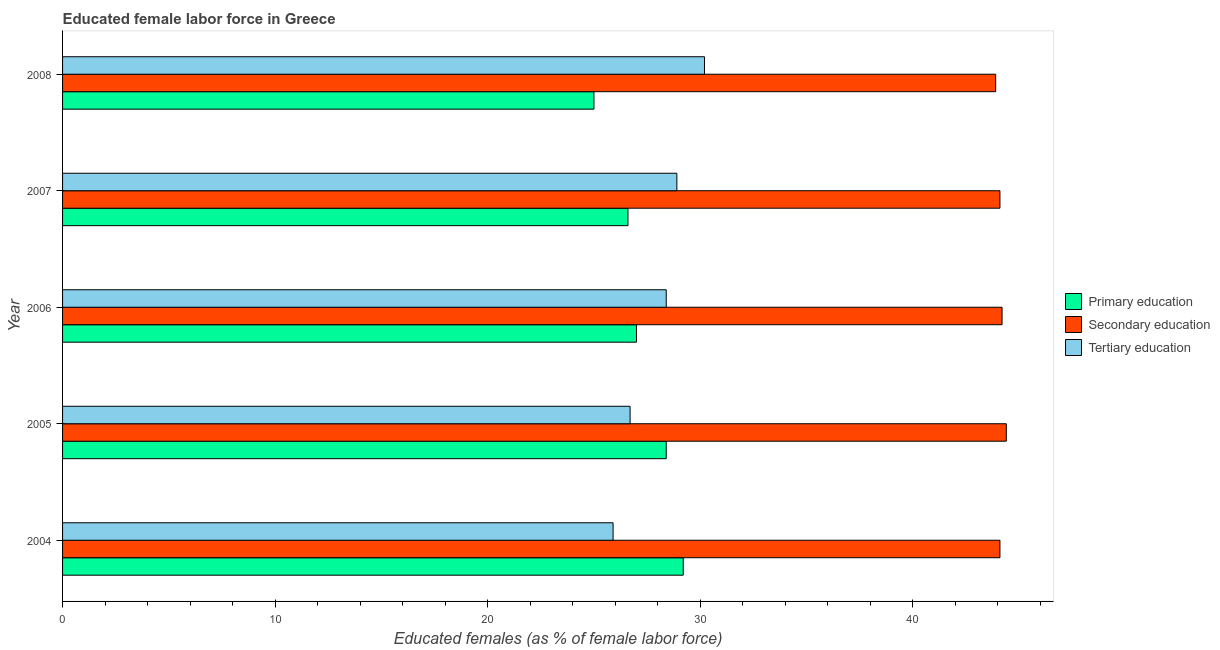How many different coloured bars are there?
Offer a terse response. 3. How many groups of bars are there?
Provide a short and direct response. 5. How many bars are there on the 4th tick from the top?
Your response must be concise. 3. What is the label of the 2nd group of bars from the top?
Keep it short and to the point. 2007. In how many cases, is the number of bars for a given year not equal to the number of legend labels?
Give a very brief answer. 0. What is the percentage of female labor force who received primary education in 2007?
Make the answer very short. 26.6. Across all years, what is the maximum percentage of female labor force who received primary education?
Give a very brief answer. 29.2. Across all years, what is the minimum percentage of female labor force who received tertiary education?
Offer a terse response. 25.9. In which year was the percentage of female labor force who received secondary education maximum?
Provide a short and direct response. 2005. What is the total percentage of female labor force who received tertiary education in the graph?
Your answer should be very brief. 140.1. What is the difference between the percentage of female labor force who received secondary education in 2004 and that in 2006?
Your answer should be compact. -0.1. What is the difference between the percentage of female labor force who received primary education in 2004 and the percentage of female labor force who received secondary education in 2007?
Keep it short and to the point. -14.9. What is the average percentage of female labor force who received tertiary education per year?
Your answer should be compact. 28.02. In the year 2005, what is the difference between the percentage of female labor force who received tertiary education and percentage of female labor force who received primary education?
Keep it short and to the point. -1.7. In how many years, is the percentage of female labor force who received secondary education greater than 32 %?
Keep it short and to the point. 5. What is the ratio of the percentage of female labor force who received secondary education in 2005 to that in 2006?
Your answer should be very brief. 1. What is the difference between the highest and the second highest percentage of female labor force who received tertiary education?
Offer a terse response. 1.3. In how many years, is the percentage of female labor force who received secondary education greater than the average percentage of female labor force who received secondary education taken over all years?
Give a very brief answer. 2. What does the 1st bar from the top in 2005 represents?
Your response must be concise. Tertiary education. What does the 2nd bar from the bottom in 2007 represents?
Make the answer very short. Secondary education. Is it the case that in every year, the sum of the percentage of female labor force who received primary education and percentage of female labor force who received secondary education is greater than the percentage of female labor force who received tertiary education?
Make the answer very short. Yes. Are all the bars in the graph horizontal?
Offer a terse response. Yes. What is the difference between two consecutive major ticks on the X-axis?
Your answer should be very brief. 10. Are the values on the major ticks of X-axis written in scientific E-notation?
Offer a terse response. No. Does the graph contain any zero values?
Provide a short and direct response. No. Where does the legend appear in the graph?
Keep it short and to the point. Center right. How are the legend labels stacked?
Ensure brevity in your answer.  Vertical. What is the title of the graph?
Ensure brevity in your answer.  Educated female labor force in Greece. Does "Poland" appear as one of the legend labels in the graph?
Provide a succinct answer. No. What is the label or title of the X-axis?
Make the answer very short. Educated females (as % of female labor force). What is the label or title of the Y-axis?
Your response must be concise. Year. What is the Educated females (as % of female labor force) in Primary education in 2004?
Provide a succinct answer. 29.2. What is the Educated females (as % of female labor force) of Secondary education in 2004?
Keep it short and to the point. 44.1. What is the Educated females (as % of female labor force) of Tertiary education in 2004?
Give a very brief answer. 25.9. What is the Educated females (as % of female labor force) in Primary education in 2005?
Give a very brief answer. 28.4. What is the Educated females (as % of female labor force) in Secondary education in 2005?
Your answer should be very brief. 44.4. What is the Educated females (as % of female labor force) of Tertiary education in 2005?
Your answer should be very brief. 26.7. What is the Educated females (as % of female labor force) of Secondary education in 2006?
Ensure brevity in your answer.  44.2. What is the Educated females (as % of female labor force) of Tertiary education in 2006?
Your response must be concise. 28.4. What is the Educated females (as % of female labor force) in Primary education in 2007?
Offer a terse response. 26.6. What is the Educated females (as % of female labor force) of Secondary education in 2007?
Offer a very short reply. 44.1. What is the Educated females (as % of female labor force) in Tertiary education in 2007?
Make the answer very short. 28.9. What is the Educated females (as % of female labor force) in Primary education in 2008?
Keep it short and to the point. 25. What is the Educated females (as % of female labor force) of Secondary education in 2008?
Your answer should be very brief. 43.9. What is the Educated females (as % of female labor force) in Tertiary education in 2008?
Provide a short and direct response. 30.2. Across all years, what is the maximum Educated females (as % of female labor force) of Primary education?
Give a very brief answer. 29.2. Across all years, what is the maximum Educated females (as % of female labor force) in Secondary education?
Your answer should be compact. 44.4. Across all years, what is the maximum Educated females (as % of female labor force) of Tertiary education?
Offer a terse response. 30.2. Across all years, what is the minimum Educated females (as % of female labor force) in Secondary education?
Keep it short and to the point. 43.9. Across all years, what is the minimum Educated females (as % of female labor force) in Tertiary education?
Your response must be concise. 25.9. What is the total Educated females (as % of female labor force) in Primary education in the graph?
Make the answer very short. 136.2. What is the total Educated females (as % of female labor force) in Secondary education in the graph?
Provide a succinct answer. 220.7. What is the total Educated females (as % of female labor force) in Tertiary education in the graph?
Keep it short and to the point. 140.1. What is the difference between the Educated females (as % of female labor force) in Secondary education in 2004 and that in 2005?
Your response must be concise. -0.3. What is the difference between the Educated females (as % of female labor force) of Primary education in 2004 and that in 2007?
Your answer should be very brief. 2.6. What is the difference between the Educated females (as % of female labor force) in Secondary education in 2004 and that in 2007?
Keep it short and to the point. 0. What is the difference between the Educated females (as % of female labor force) in Tertiary education in 2004 and that in 2007?
Your answer should be very brief. -3. What is the difference between the Educated females (as % of female labor force) in Primary education in 2004 and that in 2008?
Your answer should be compact. 4.2. What is the difference between the Educated females (as % of female labor force) of Secondary education in 2004 and that in 2008?
Make the answer very short. 0.2. What is the difference between the Educated females (as % of female labor force) of Tertiary education in 2005 and that in 2006?
Provide a succinct answer. -1.7. What is the difference between the Educated females (as % of female labor force) of Primary education in 2005 and that in 2007?
Keep it short and to the point. 1.8. What is the difference between the Educated females (as % of female labor force) of Tertiary education in 2005 and that in 2007?
Offer a very short reply. -2.2. What is the difference between the Educated females (as % of female labor force) in Tertiary education in 2005 and that in 2008?
Provide a short and direct response. -3.5. What is the difference between the Educated females (as % of female labor force) in Primary education in 2006 and that in 2007?
Offer a very short reply. 0.4. What is the difference between the Educated females (as % of female labor force) of Primary education in 2006 and that in 2008?
Give a very brief answer. 2. What is the difference between the Educated females (as % of female labor force) of Secondary education in 2006 and that in 2008?
Your answer should be very brief. 0.3. What is the difference between the Educated females (as % of female labor force) of Secondary education in 2007 and that in 2008?
Ensure brevity in your answer.  0.2. What is the difference between the Educated females (as % of female labor force) in Primary education in 2004 and the Educated females (as % of female labor force) in Secondary education in 2005?
Your response must be concise. -15.2. What is the difference between the Educated females (as % of female labor force) of Primary education in 2004 and the Educated females (as % of female labor force) of Secondary education in 2006?
Give a very brief answer. -15. What is the difference between the Educated females (as % of female labor force) in Primary education in 2004 and the Educated females (as % of female labor force) in Tertiary education in 2006?
Your answer should be very brief. 0.8. What is the difference between the Educated females (as % of female labor force) in Primary education in 2004 and the Educated females (as % of female labor force) in Secondary education in 2007?
Provide a short and direct response. -14.9. What is the difference between the Educated females (as % of female labor force) in Primary education in 2004 and the Educated females (as % of female labor force) in Tertiary education in 2007?
Give a very brief answer. 0.3. What is the difference between the Educated females (as % of female labor force) of Primary education in 2004 and the Educated females (as % of female labor force) of Secondary education in 2008?
Give a very brief answer. -14.7. What is the difference between the Educated females (as % of female labor force) in Primary education in 2005 and the Educated females (as % of female labor force) in Secondary education in 2006?
Your response must be concise. -15.8. What is the difference between the Educated females (as % of female labor force) in Primary education in 2005 and the Educated females (as % of female labor force) in Tertiary education in 2006?
Your answer should be compact. 0. What is the difference between the Educated females (as % of female labor force) in Primary education in 2005 and the Educated females (as % of female labor force) in Secondary education in 2007?
Give a very brief answer. -15.7. What is the difference between the Educated females (as % of female labor force) of Secondary education in 2005 and the Educated females (as % of female labor force) of Tertiary education in 2007?
Offer a very short reply. 15.5. What is the difference between the Educated females (as % of female labor force) in Primary education in 2005 and the Educated females (as % of female labor force) in Secondary education in 2008?
Give a very brief answer. -15.5. What is the difference between the Educated females (as % of female labor force) of Secondary education in 2005 and the Educated females (as % of female labor force) of Tertiary education in 2008?
Offer a very short reply. 14.2. What is the difference between the Educated females (as % of female labor force) in Primary education in 2006 and the Educated females (as % of female labor force) in Secondary education in 2007?
Offer a very short reply. -17.1. What is the difference between the Educated females (as % of female labor force) in Primary education in 2006 and the Educated females (as % of female labor force) in Secondary education in 2008?
Provide a short and direct response. -16.9. What is the difference between the Educated females (as % of female labor force) of Primary education in 2007 and the Educated females (as % of female labor force) of Secondary education in 2008?
Your answer should be compact. -17.3. What is the difference between the Educated females (as % of female labor force) in Primary education in 2007 and the Educated females (as % of female labor force) in Tertiary education in 2008?
Provide a short and direct response. -3.6. What is the difference between the Educated females (as % of female labor force) in Secondary education in 2007 and the Educated females (as % of female labor force) in Tertiary education in 2008?
Offer a very short reply. 13.9. What is the average Educated females (as % of female labor force) of Primary education per year?
Give a very brief answer. 27.24. What is the average Educated females (as % of female labor force) in Secondary education per year?
Offer a terse response. 44.14. What is the average Educated females (as % of female labor force) in Tertiary education per year?
Your response must be concise. 28.02. In the year 2004, what is the difference between the Educated females (as % of female labor force) of Primary education and Educated females (as % of female labor force) of Secondary education?
Offer a very short reply. -14.9. In the year 2005, what is the difference between the Educated females (as % of female labor force) in Primary education and Educated females (as % of female labor force) in Secondary education?
Give a very brief answer. -16. In the year 2005, what is the difference between the Educated females (as % of female labor force) in Primary education and Educated females (as % of female labor force) in Tertiary education?
Provide a succinct answer. 1.7. In the year 2006, what is the difference between the Educated females (as % of female labor force) of Primary education and Educated females (as % of female labor force) of Secondary education?
Make the answer very short. -17.2. In the year 2007, what is the difference between the Educated females (as % of female labor force) in Primary education and Educated females (as % of female labor force) in Secondary education?
Your answer should be compact. -17.5. In the year 2008, what is the difference between the Educated females (as % of female labor force) in Primary education and Educated females (as % of female labor force) in Secondary education?
Make the answer very short. -18.9. In the year 2008, what is the difference between the Educated females (as % of female labor force) in Primary education and Educated females (as % of female labor force) in Tertiary education?
Keep it short and to the point. -5.2. In the year 2008, what is the difference between the Educated females (as % of female labor force) in Secondary education and Educated females (as % of female labor force) in Tertiary education?
Offer a very short reply. 13.7. What is the ratio of the Educated females (as % of female labor force) of Primary education in 2004 to that in 2005?
Your answer should be compact. 1.03. What is the ratio of the Educated females (as % of female labor force) in Secondary education in 2004 to that in 2005?
Your response must be concise. 0.99. What is the ratio of the Educated females (as % of female labor force) of Tertiary education in 2004 to that in 2005?
Your answer should be very brief. 0.97. What is the ratio of the Educated females (as % of female labor force) of Primary education in 2004 to that in 2006?
Provide a succinct answer. 1.08. What is the ratio of the Educated females (as % of female labor force) of Tertiary education in 2004 to that in 2006?
Provide a succinct answer. 0.91. What is the ratio of the Educated females (as % of female labor force) of Primary education in 2004 to that in 2007?
Ensure brevity in your answer.  1.1. What is the ratio of the Educated females (as % of female labor force) in Secondary education in 2004 to that in 2007?
Your answer should be compact. 1. What is the ratio of the Educated females (as % of female labor force) in Tertiary education in 2004 to that in 2007?
Your answer should be compact. 0.9. What is the ratio of the Educated females (as % of female labor force) of Primary education in 2004 to that in 2008?
Offer a very short reply. 1.17. What is the ratio of the Educated females (as % of female labor force) in Tertiary education in 2004 to that in 2008?
Keep it short and to the point. 0.86. What is the ratio of the Educated females (as % of female labor force) of Primary education in 2005 to that in 2006?
Make the answer very short. 1.05. What is the ratio of the Educated females (as % of female labor force) in Secondary education in 2005 to that in 2006?
Your answer should be very brief. 1. What is the ratio of the Educated females (as % of female labor force) of Tertiary education in 2005 to that in 2006?
Offer a terse response. 0.94. What is the ratio of the Educated females (as % of female labor force) of Primary education in 2005 to that in 2007?
Provide a short and direct response. 1.07. What is the ratio of the Educated females (as % of female labor force) in Secondary education in 2005 to that in 2007?
Give a very brief answer. 1.01. What is the ratio of the Educated females (as % of female labor force) in Tertiary education in 2005 to that in 2007?
Ensure brevity in your answer.  0.92. What is the ratio of the Educated females (as % of female labor force) in Primary education in 2005 to that in 2008?
Give a very brief answer. 1.14. What is the ratio of the Educated females (as % of female labor force) in Secondary education in 2005 to that in 2008?
Your answer should be very brief. 1.01. What is the ratio of the Educated females (as % of female labor force) in Tertiary education in 2005 to that in 2008?
Offer a very short reply. 0.88. What is the ratio of the Educated females (as % of female labor force) in Primary education in 2006 to that in 2007?
Keep it short and to the point. 1.01. What is the ratio of the Educated females (as % of female labor force) of Tertiary education in 2006 to that in 2007?
Ensure brevity in your answer.  0.98. What is the ratio of the Educated females (as % of female labor force) in Secondary education in 2006 to that in 2008?
Your answer should be compact. 1.01. What is the ratio of the Educated females (as % of female labor force) in Tertiary education in 2006 to that in 2008?
Give a very brief answer. 0.94. What is the ratio of the Educated females (as % of female labor force) in Primary education in 2007 to that in 2008?
Ensure brevity in your answer.  1.06. What is the ratio of the Educated females (as % of female labor force) in Tertiary education in 2007 to that in 2008?
Give a very brief answer. 0.96. What is the difference between the highest and the second highest Educated females (as % of female labor force) of Primary education?
Give a very brief answer. 0.8. What is the difference between the highest and the lowest Educated females (as % of female labor force) of Secondary education?
Provide a succinct answer. 0.5. 